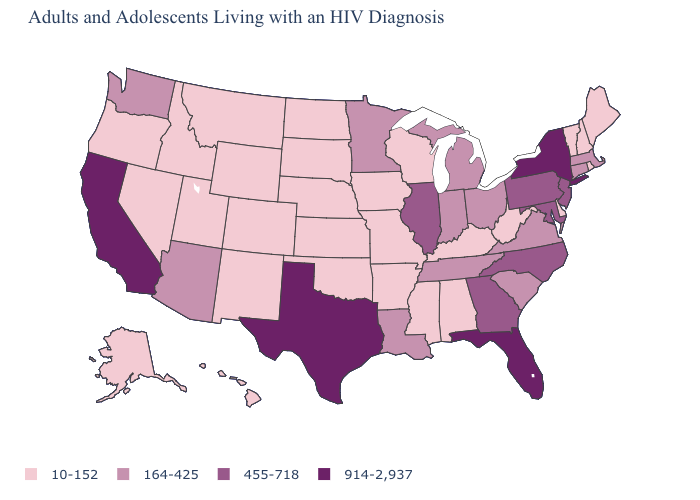Does Oklahoma have a higher value than Utah?
Concise answer only. No. What is the lowest value in the USA?
Write a very short answer. 10-152. What is the value of North Carolina?
Quick response, please. 455-718. What is the value of Virginia?
Be succinct. 164-425. What is the value of Tennessee?
Give a very brief answer. 164-425. Does the first symbol in the legend represent the smallest category?
Short answer required. Yes. Does the first symbol in the legend represent the smallest category?
Keep it brief. Yes. What is the value of Rhode Island?
Concise answer only. 10-152. Which states have the lowest value in the USA?
Concise answer only. Alabama, Alaska, Arkansas, Colorado, Delaware, Hawaii, Idaho, Iowa, Kansas, Kentucky, Maine, Mississippi, Missouri, Montana, Nebraska, Nevada, New Hampshire, New Mexico, North Dakota, Oklahoma, Oregon, Rhode Island, South Dakota, Utah, Vermont, West Virginia, Wisconsin, Wyoming. What is the value of Missouri?
Answer briefly. 10-152. Does North Carolina have a higher value than Maine?
Give a very brief answer. Yes. What is the highest value in the Northeast ?
Short answer required. 914-2,937. What is the value of Massachusetts?
Write a very short answer. 164-425. Which states have the highest value in the USA?
Quick response, please. California, Florida, New York, Texas. 